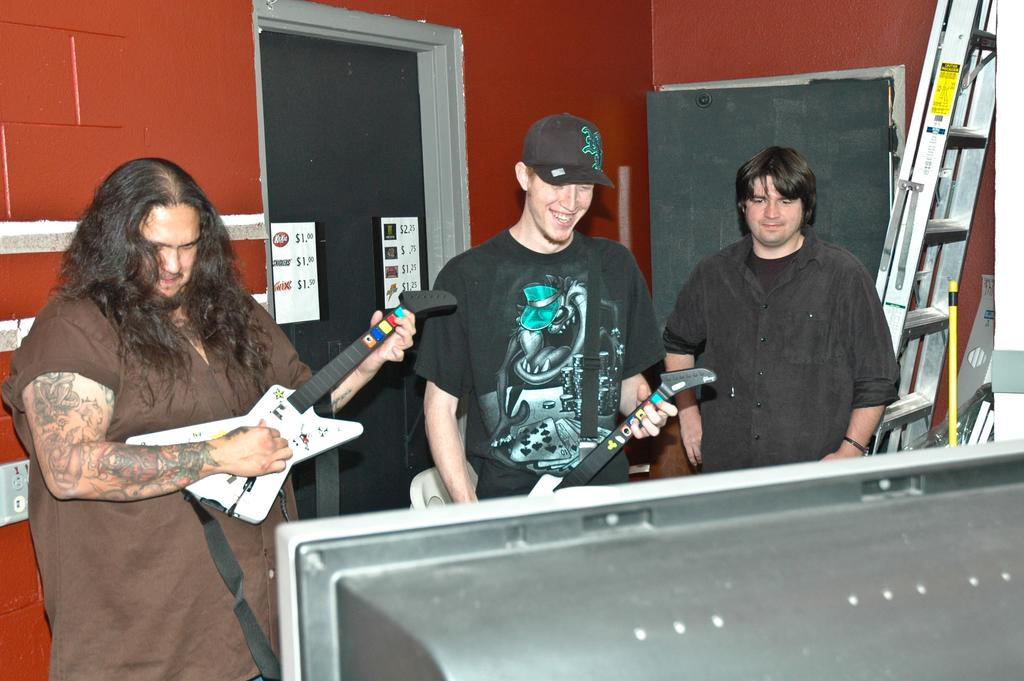What can be seen in the background of the image? There is a wall and a ladder in the background of the image. How many people are present in the image? There are three persons standing in the image. What are two of the persons doing in the image? Two of the persons are playing musical instruments. What is the facial expression of the two persons playing musical instruments? The two persons playing musical instruments are smiling. Can you see any clover growing near the ladder in the image? There is no clover visible in the image; it only features a wall, a ladder, and three persons. What type of care is being provided to the mice in the image? There are no mice present in the image, so no care is being provided. 